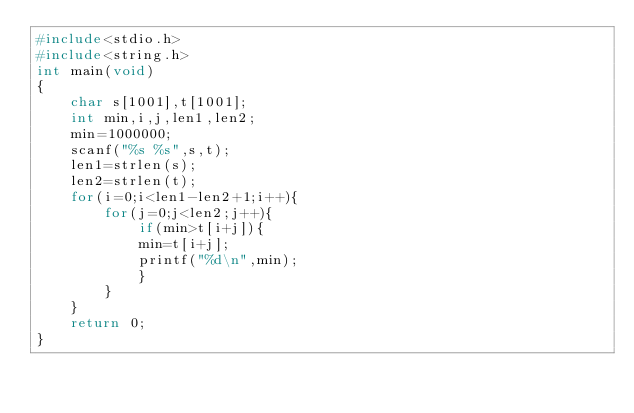Convert code to text. <code><loc_0><loc_0><loc_500><loc_500><_C_>#include<stdio.h>
#include<string.h>
int main(void)
{
	char s[1001],t[1001];
	int min,i,j,len1,len2;
	min=1000000;
	scanf("%s %s",s,t);
	len1=strlen(s);
	len2=strlen(t);
	for(i=0;i<len1-len2+1;i++){
		for(j=0;j<len2;j++){
			if(min>t[i+j]){
			min=t[i+j];
			printf("%d\n",min);
			}
		}
	}
	return 0;
}</code> 